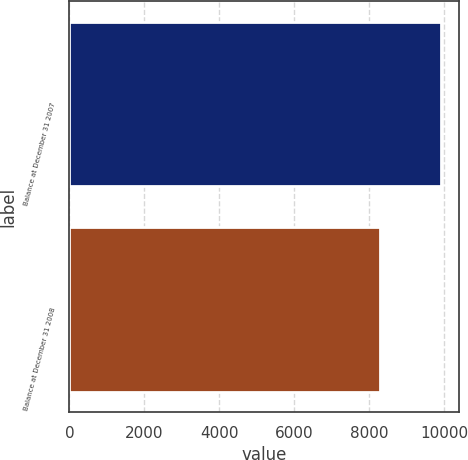Convert chart to OTSL. <chart><loc_0><loc_0><loc_500><loc_500><bar_chart><fcel>Balance at December 31 2007<fcel>Balance at December 31 2008<nl><fcel>9919<fcel>8283<nl></chart> 